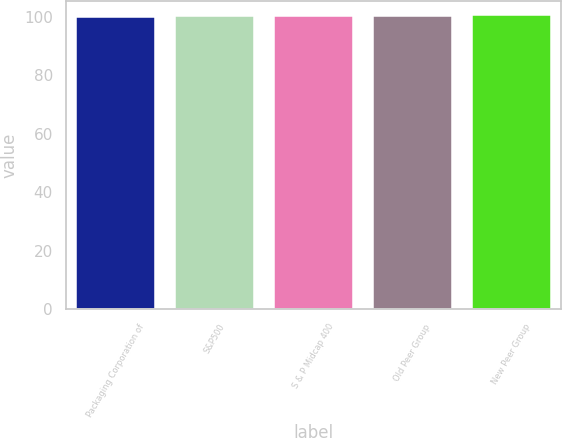Convert chart. <chart><loc_0><loc_0><loc_500><loc_500><bar_chart><fcel>Packaging Corporation of<fcel>S&P500<fcel>S & P Midcap 400<fcel>Old Peer Group<fcel>New Peer Group<nl><fcel>100<fcel>100.1<fcel>100.2<fcel>100.3<fcel>100.4<nl></chart> 